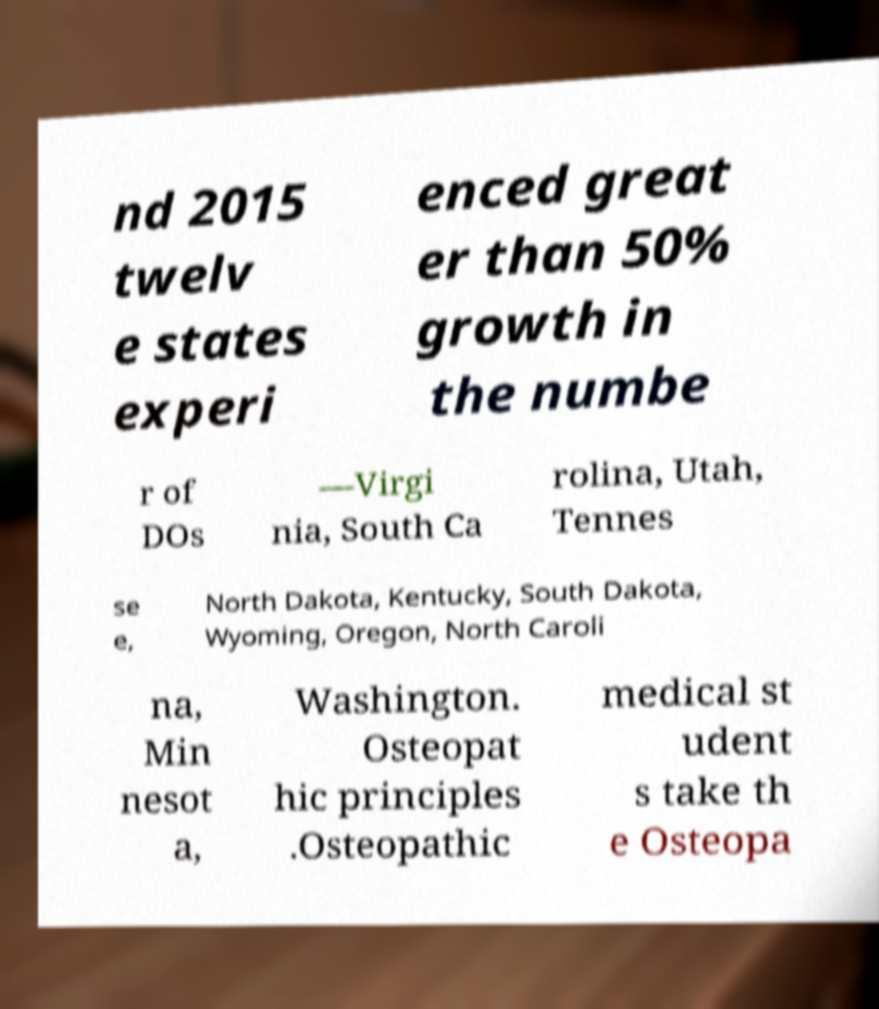I need the written content from this picture converted into text. Can you do that? nd 2015 twelv e states experi enced great er than 50% growth in the numbe r of DOs —Virgi nia, South Ca rolina, Utah, Tennes se e, North Dakota, Kentucky, South Dakota, Wyoming, Oregon, North Caroli na, Min nesot a, Washington. Osteopat hic principles .Osteopathic medical st udent s take th e Osteopa 